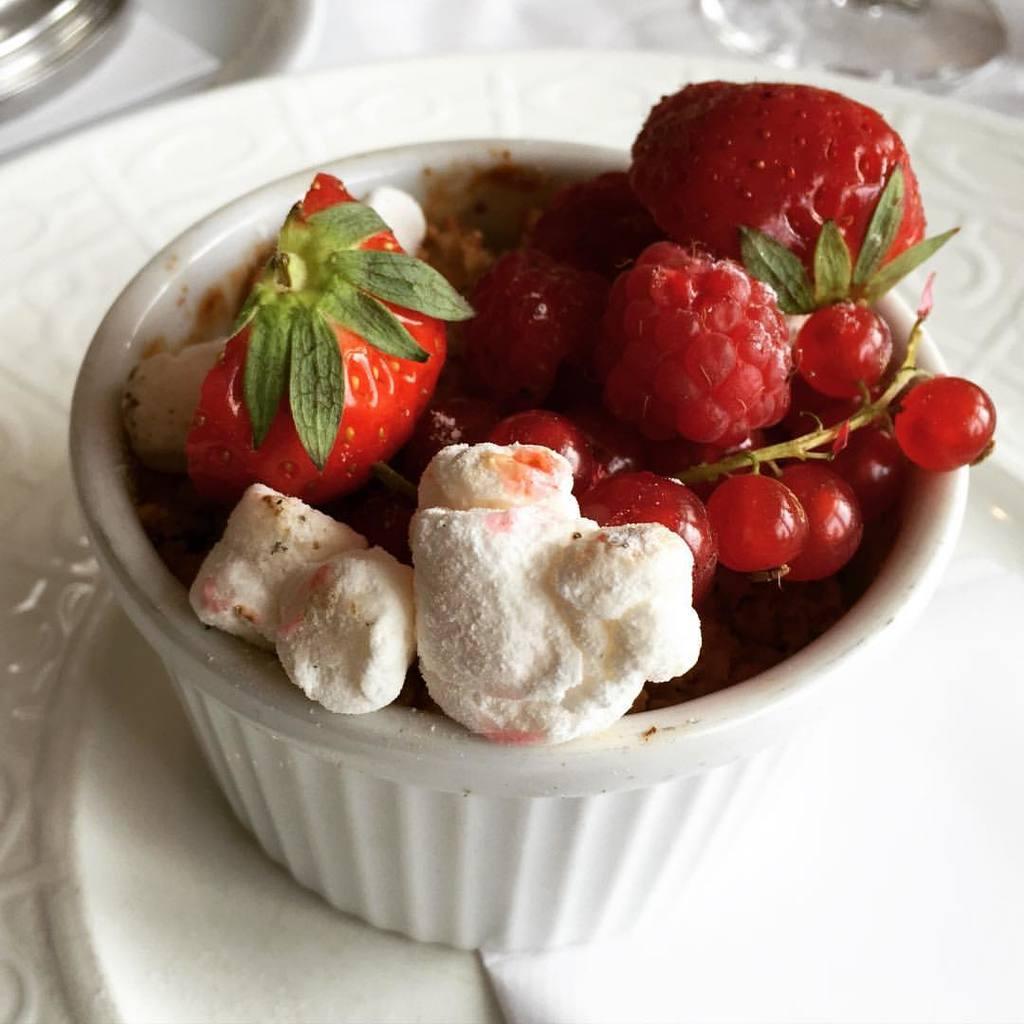Describe this image in one or two sentences. In this picture there is a food in the bowl. There are plates there is a glass, bowl and tissue on the table and the table is covered with white color cloth. 